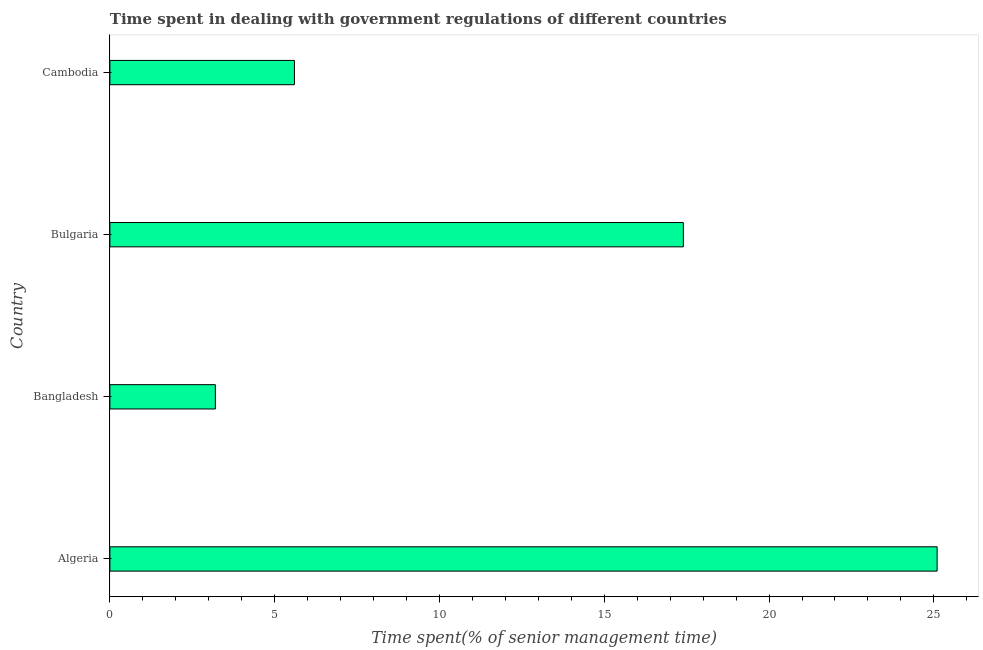Does the graph contain any zero values?
Keep it short and to the point. No. What is the title of the graph?
Keep it short and to the point. Time spent in dealing with government regulations of different countries. What is the label or title of the X-axis?
Your answer should be compact. Time spent(% of senior management time). What is the label or title of the Y-axis?
Your response must be concise. Country. What is the time spent in dealing with government regulations in Bulgaria?
Offer a very short reply. 17.4. Across all countries, what is the maximum time spent in dealing with government regulations?
Your response must be concise. 25.1. Across all countries, what is the minimum time spent in dealing with government regulations?
Provide a succinct answer. 3.2. In which country was the time spent in dealing with government regulations maximum?
Provide a succinct answer. Algeria. In which country was the time spent in dealing with government regulations minimum?
Keep it short and to the point. Bangladesh. What is the sum of the time spent in dealing with government regulations?
Offer a very short reply. 51.3. What is the average time spent in dealing with government regulations per country?
Make the answer very short. 12.82. In how many countries, is the time spent in dealing with government regulations greater than 17 %?
Ensure brevity in your answer.  2. What is the ratio of the time spent in dealing with government regulations in Algeria to that in Bulgaria?
Your answer should be very brief. 1.44. Is the sum of the time spent in dealing with government regulations in Algeria and Cambodia greater than the maximum time spent in dealing with government regulations across all countries?
Offer a terse response. Yes. What is the difference between the highest and the lowest time spent in dealing with government regulations?
Give a very brief answer. 21.9. In how many countries, is the time spent in dealing with government regulations greater than the average time spent in dealing with government regulations taken over all countries?
Give a very brief answer. 2. How many bars are there?
Your answer should be compact. 4. What is the difference between two consecutive major ticks on the X-axis?
Provide a short and direct response. 5. What is the Time spent(% of senior management time) of Algeria?
Offer a terse response. 25.1. What is the difference between the Time spent(% of senior management time) in Algeria and Bangladesh?
Make the answer very short. 21.9. What is the difference between the Time spent(% of senior management time) in Algeria and Bulgaria?
Provide a succinct answer. 7.7. What is the difference between the Time spent(% of senior management time) in Algeria and Cambodia?
Provide a succinct answer. 19.5. What is the ratio of the Time spent(% of senior management time) in Algeria to that in Bangladesh?
Your answer should be very brief. 7.84. What is the ratio of the Time spent(% of senior management time) in Algeria to that in Bulgaria?
Provide a succinct answer. 1.44. What is the ratio of the Time spent(% of senior management time) in Algeria to that in Cambodia?
Provide a short and direct response. 4.48. What is the ratio of the Time spent(% of senior management time) in Bangladesh to that in Bulgaria?
Your answer should be compact. 0.18. What is the ratio of the Time spent(% of senior management time) in Bangladesh to that in Cambodia?
Your answer should be compact. 0.57. What is the ratio of the Time spent(% of senior management time) in Bulgaria to that in Cambodia?
Make the answer very short. 3.11. 